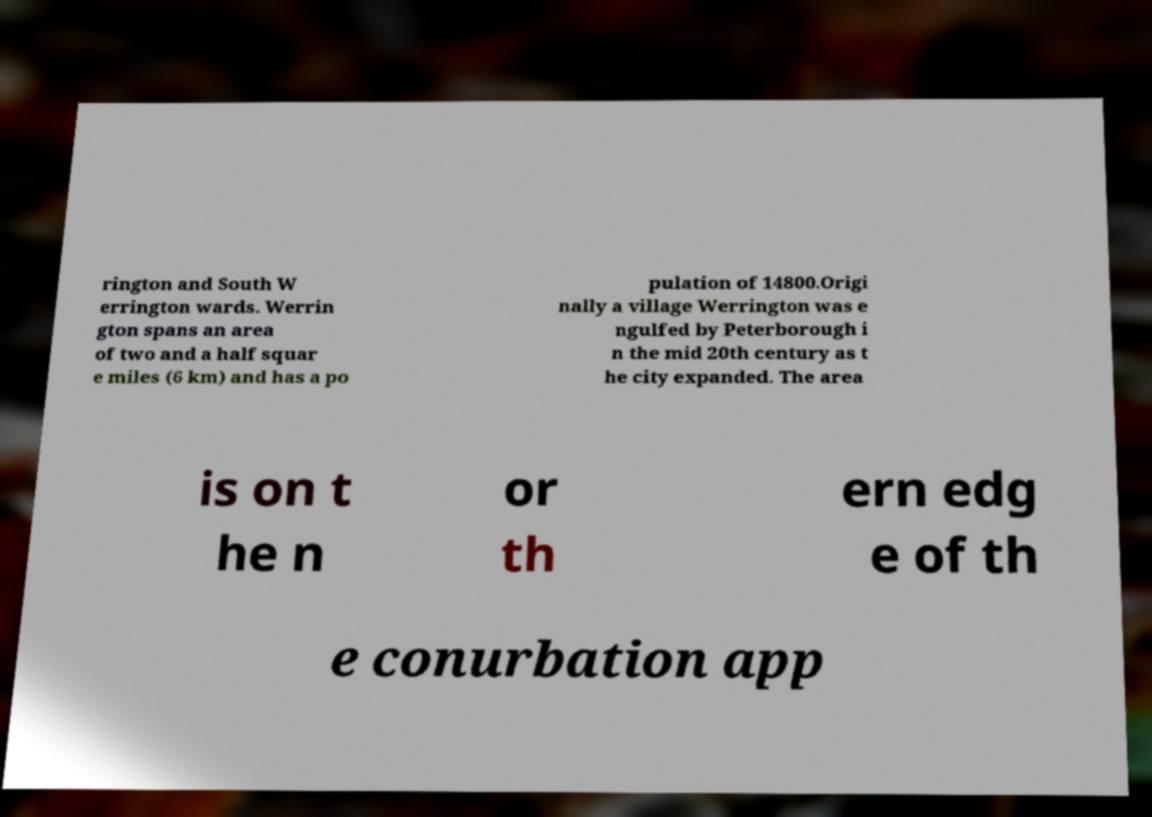Please read and relay the text visible in this image. What does it say? rington and South W errington wards. Werrin gton spans an area of two and a half squar e miles (6 km) and has a po pulation of 14800.Origi nally a village Werrington was e ngulfed by Peterborough i n the mid 20th century as t he city expanded. The area is on t he n or th ern edg e of th e conurbation app 